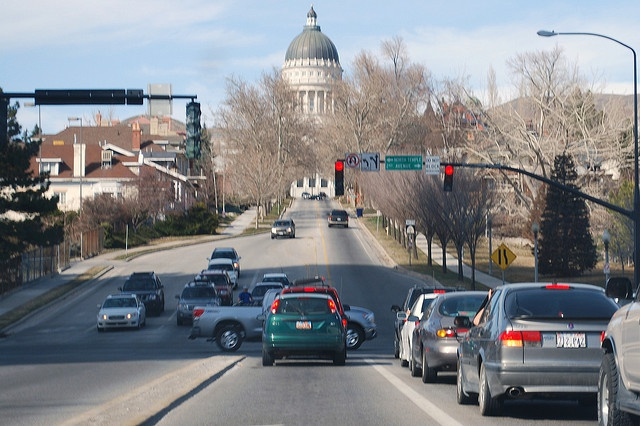Describe the objects in this image and their specific colors. I can see car in lightgray, gray, darkgray, navy, and black tones, car in lightgray, black, blue, gray, and navy tones, car in lightgray, teal, black, darkblue, and gray tones, car in lightgray, darkgray, gray, black, and darkblue tones, and truck in lightgray, black, gray, and blue tones in this image. 